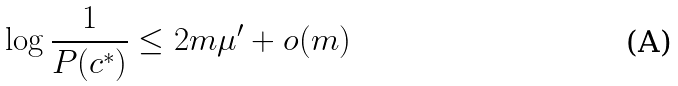Convert formula to latex. <formula><loc_0><loc_0><loc_500><loc_500>\log \frac { 1 } { P ( c ^ { * } ) } \leq 2 m \mu ^ { \prime } + o ( m )</formula> 